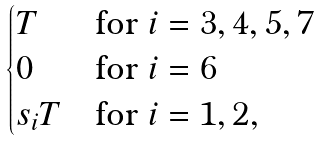Convert formula to latex. <formula><loc_0><loc_0><loc_500><loc_500>\begin{cases} T & \text {for $i=3,4,5,7$} \\ 0 & \text {for $i=6$} \\ s _ { i } T & \text {for $i=1,2$} , \end{cases}</formula> 